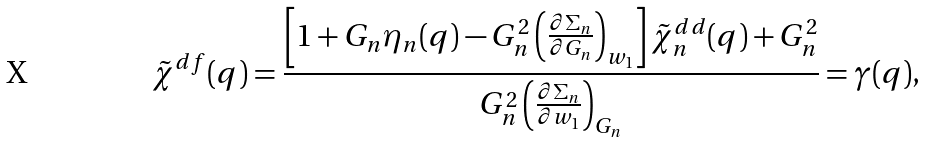Convert formula to latex. <formula><loc_0><loc_0><loc_500><loc_500>\tilde { \chi } ^ { d f } ( q ) = \frac { \left [ 1 + G _ { n } \eta _ { n } ( q ) - G _ { n } ^ { 2 } \left ( \frac { \partial \Sigma _ { n } } { \partial G _ { n } } \right ) _ { w _ { 1 } } \right ] \tilde { \chi } _ { n } ^ { d d } ( q ) + G _ { n } ^ { 2 } } { G _ { n } ^ { 2 } \left ( \frac { \partial \Sigma _ { n } } { \partial w _ { 1 } } \right ) _ { G _ { n } } } = \gamma ( q ) ,</formula> 